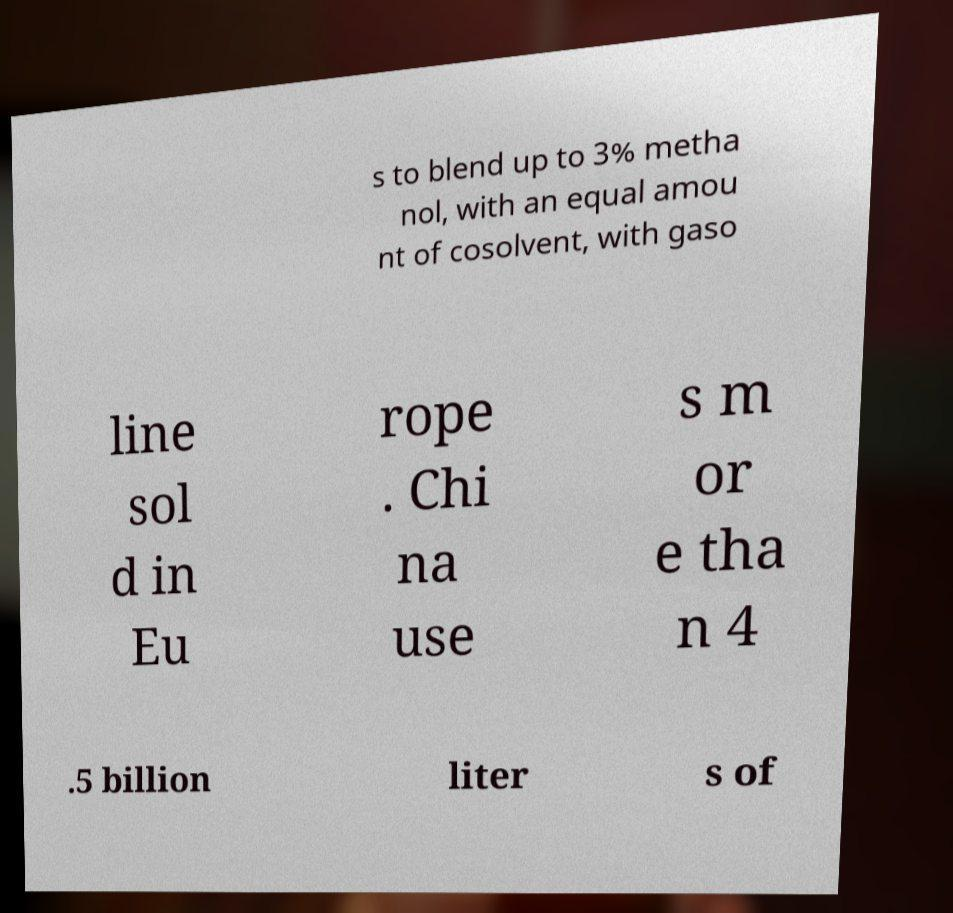Could you extract and type out the text from this image? s to blend up to 3% metha nol, with an equal amou nt of cosolvent, with gaso line sol d in Eu rope . Chi na use s m or e tha n 4 .5 billion liter s of 